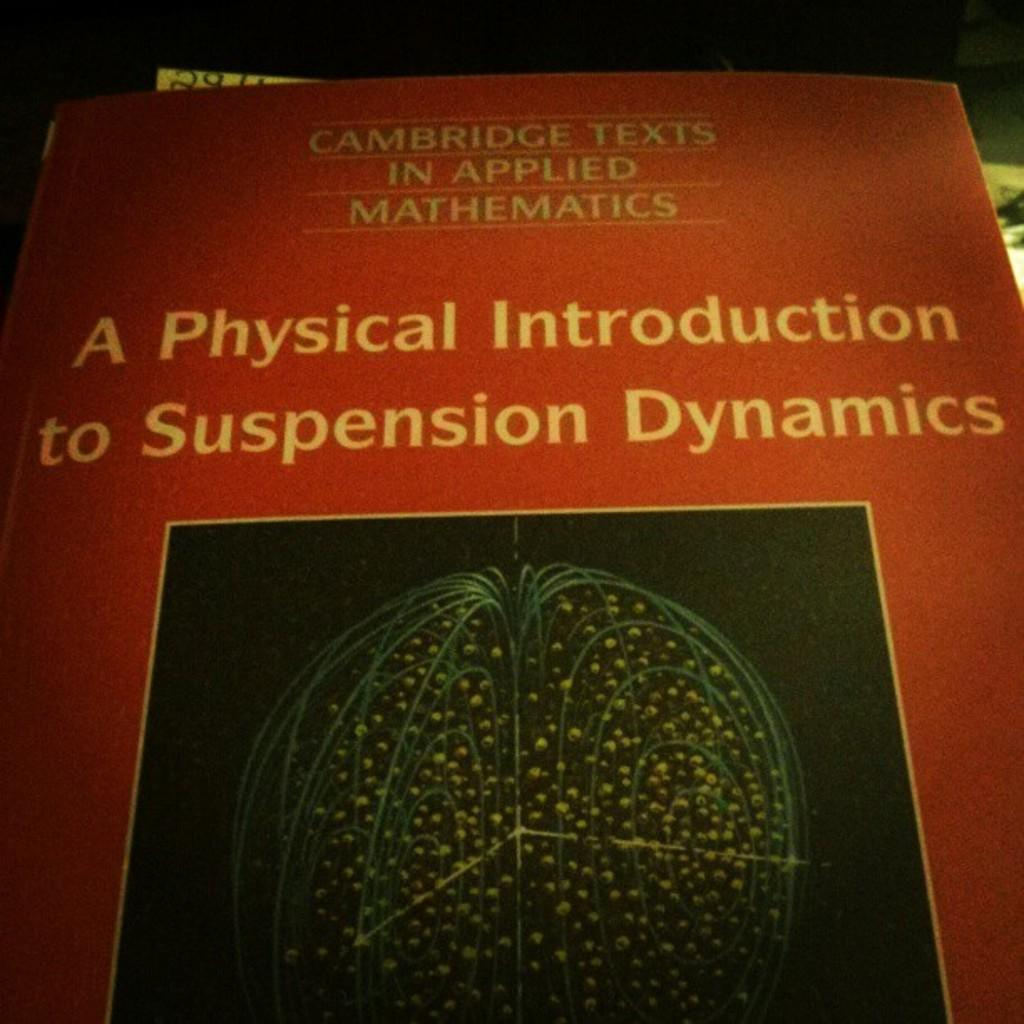<image>
Write a terse but informative summary of the picture. A red book cover with the title A Physical Introduction to Suspension Dynamics. 